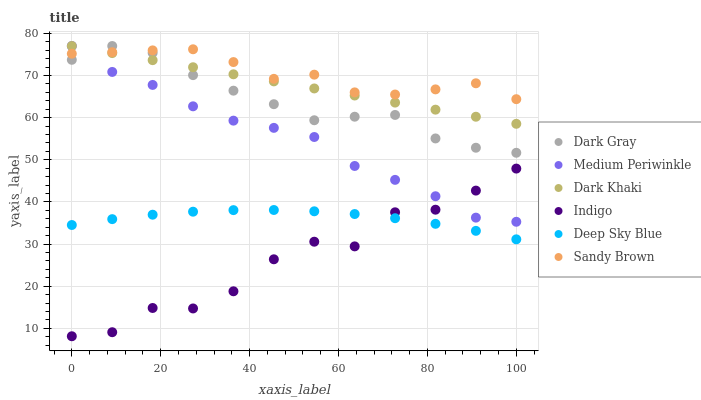Does Indigo have the minimum area under the curve?
Answer yes or no. Yes. Does Sandy Brown have the maximum area under the curve?
Answer yes or no. Yes. Does Medium Periwinkle have the minimum area under the curve?
Answer yes or no. No. Does Medium Periwinkle have the maximum area under the curve?
Answer yes or no. No. Is Dark Khaki the smoothest?
Answer yes or no. Yes. Is Indigo the roughest?
Answer yes or no. Yes. Is Medium Periwinkle the smoothest?
Answer yes or no. No. Is Medium Periwinkle the roughest?
Answer yes or no. No. Does Indigo have the lowest value?
Answer yes or no. Yes. Does Medium Periwinkle have the lowest value?
Answer yes or no. No. Does Dark Gray have the highest value?
Answer yes or no. Yes. Does Indigo have the highest value?
Answer yes or no. No. Is Deep Sky Blue less than Dark Gray?
Answer yes or no. Yes. Is Sandy Brown greater than Deep Sky Blue?
Answer yes or no. Yes. Does Medium Periwinkle intersect Indigo?
Answer yes or no. Yes. Is Medium Periwinkle less than Indigo?
Answer yes or no. No. Is Medium Periwinkle greater than Indigo?
Answer yes or no. No. Does Deep Sky Blue intersect Dark Gray?
Answer yes or no. No. 